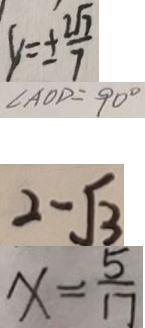<formula> <loc_0><loc_0><loc_500><loc_500>y = \pm \frac { 2 \sqrt { 7 } } { 7 } 
 \angle A O D = 9 0 ^ { \circ } 
 2 - \sqrt { 3 } 
 x = \frac { 5 } { 1 7 }</formula> 